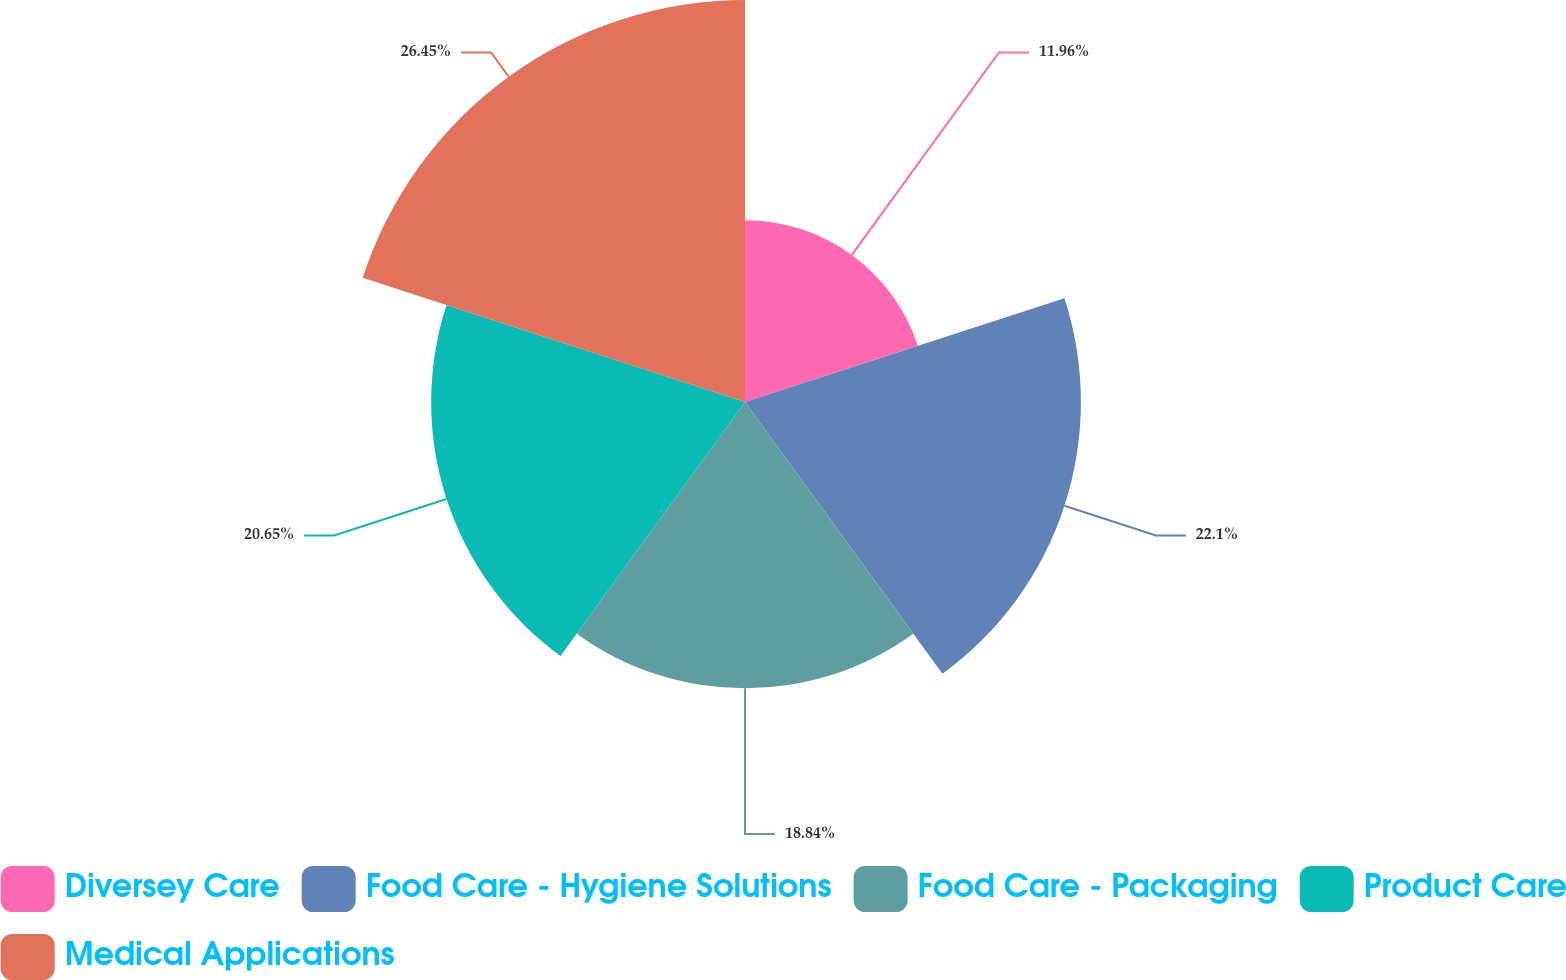Convert chart. <chart><loc_0><loc_0><loc_500><loc_500><pie_chart><fcel>Diversey Care<fcel>Food Care - Hygiene Solutions<fcel>Food Care - Packaging<fcel>Product Care<fcel>Medical Applications<nl><fcel>11.96%<fcel>22.1%<fcel>18.84%<fcel>20.65%<fcel>26.45%<nl></chart> 